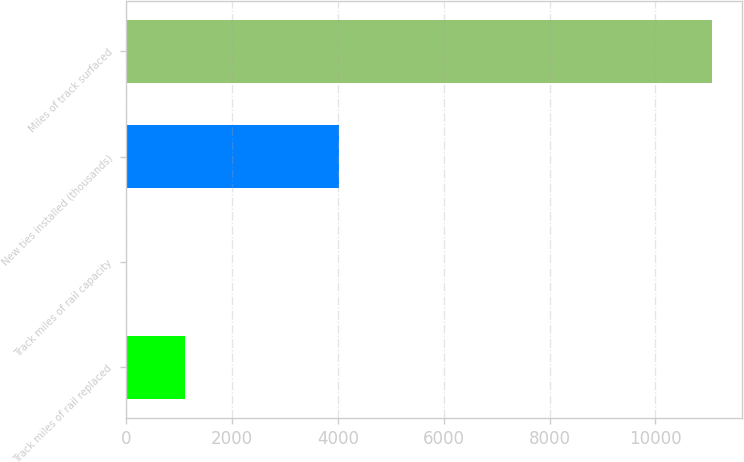<chart> <loc_0><loc_0><loc_500><loc_500><bar_chart><fcel>Track miles of rail replaced<fcel>Track miles of rail capacity<fcel>New ties installed (thousands)<fcel>Miles of track surfaced<nl><fcel>1117<fcel>11<fcel>4026<fcel>11071<nl></chart> 